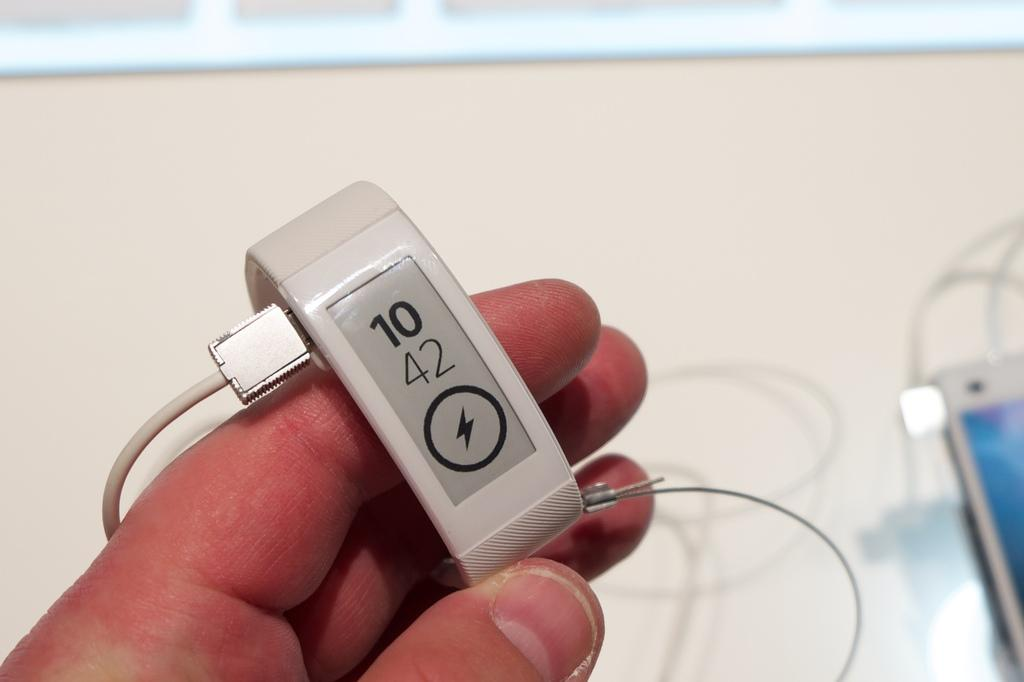Provide a one-sentence caption for the provided image. A person is holding a fitbit that is charging, it reads 10 42. 